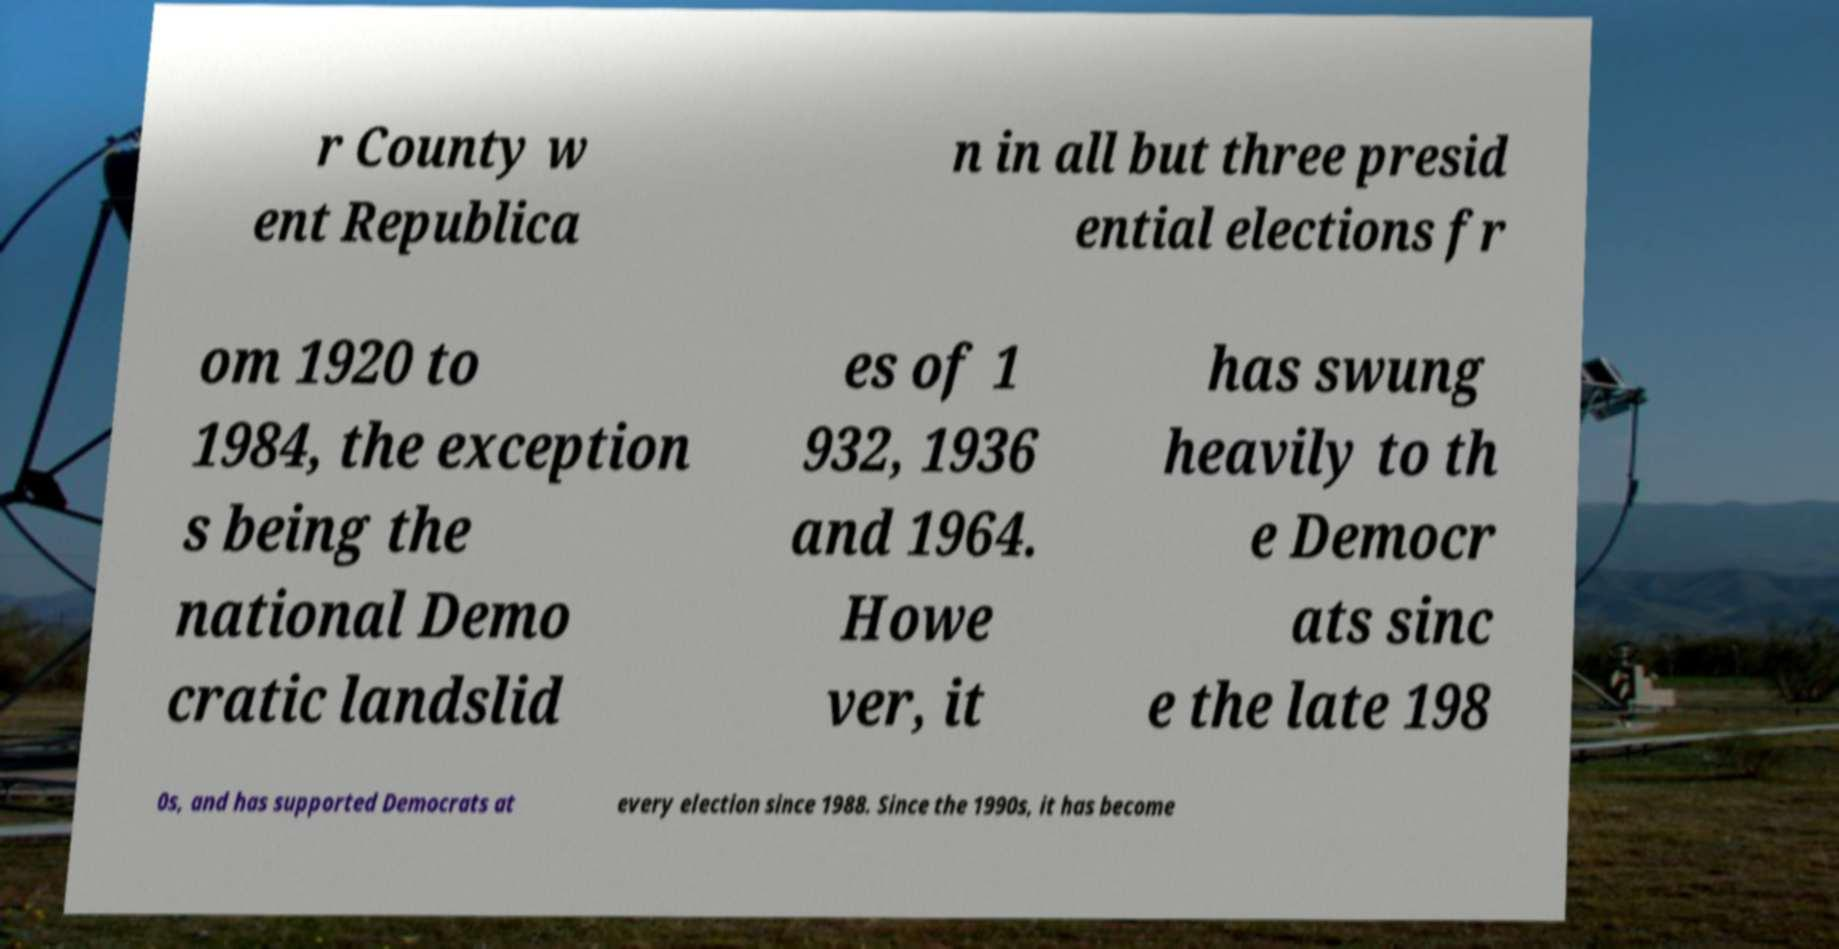Could you assist in decoding the text presented in this image and type it out clearly? r County w ent Republica n in all but three presid ential elections fr om 1920 to 1984, the exception s being the national Demo cratic landslid es of 1 932, 1936 and 1964. Howe ver, it has swung heavily to th e Democr ats sinc e the late 198 0s, and has supported Democrats at every election since 1988. Since the 1990s, it has become 